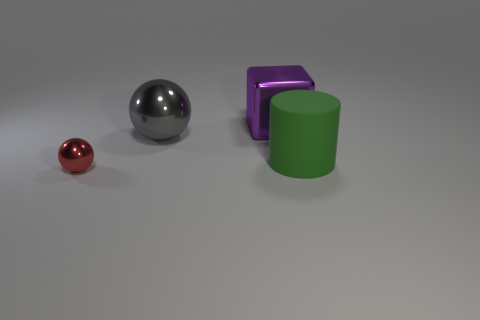There is a red object that is the same shape as the large gray shiny object; what size is it?
Ensure brevity in your answer.  Small. Are there any other things that are the same size as the red metal ball?
Offer a very short reply. No. There is a metallic cube; does it have the same size as the sphere left of the gray ball?
Provide a succinct answer. No. What is the shape of the big object that is right of the large cube?
Offer a very short reply. Cylinder. There is a big object in front of the big metallic object in front of the purple shiny thing; what is its color?
Your response must be concise. Green. There is another shiny thing that is the same shape as the tiny metal thing; what is its color?
Your answer should be compact. Gray. How many big matte cylinders are the same color as the cube?
Make the answer very short. 0. There is a metallic object that is both right of the red sphere and in front of the large purple metallic cube; what shape is it?
Keep it short and to the point. Sphere. What material is the object behind the metal ball behind the shiny sphere that is in front of the big green rubber cylinder?
Your answer should be very brief. Metal. Is the number of big cubes behind the tiny shiny object greater than the number of green matte things behind the large green matte cylinder?
Provide a short and direct response. Yes. 